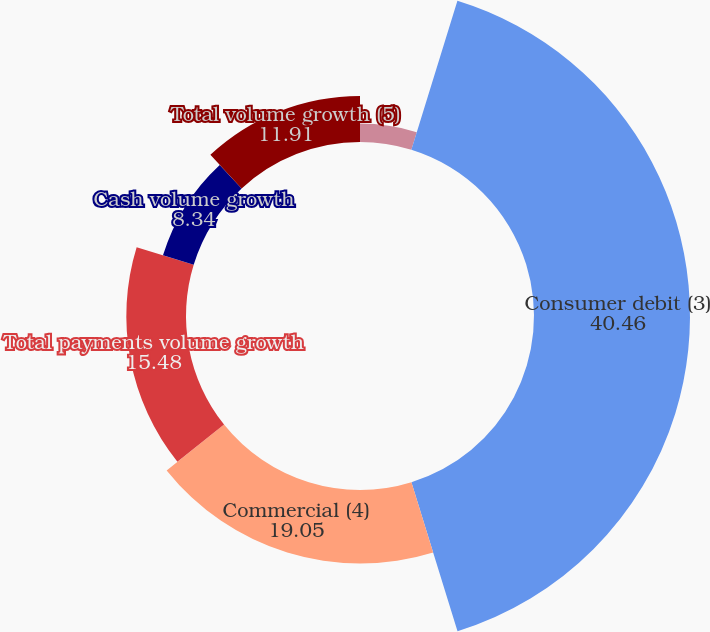<chart> <loc_0><loc_0><loc_500><loc_500><pie_chart><fcel>Consumer credit<fcel>Consumer debit (3)<fcel>Commercial (4)<fcel>Total payments volume growth<fcel>Cash volume growth<fcel>Total volume growth (5)<nl><fcel>4.77%<fcel>40.46%<fcel>19.05%<fcel>15.48%<fcel>8.34%<fcel>11.91%<nl></chart> 